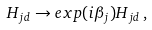Convert formula to latex. <formula><loc_0><loc_0><loc_500><loc_500>H _ { j d } \rightarrow e x p ( i \beta _ { j } ) H _ { j d } \, ,</formula> 